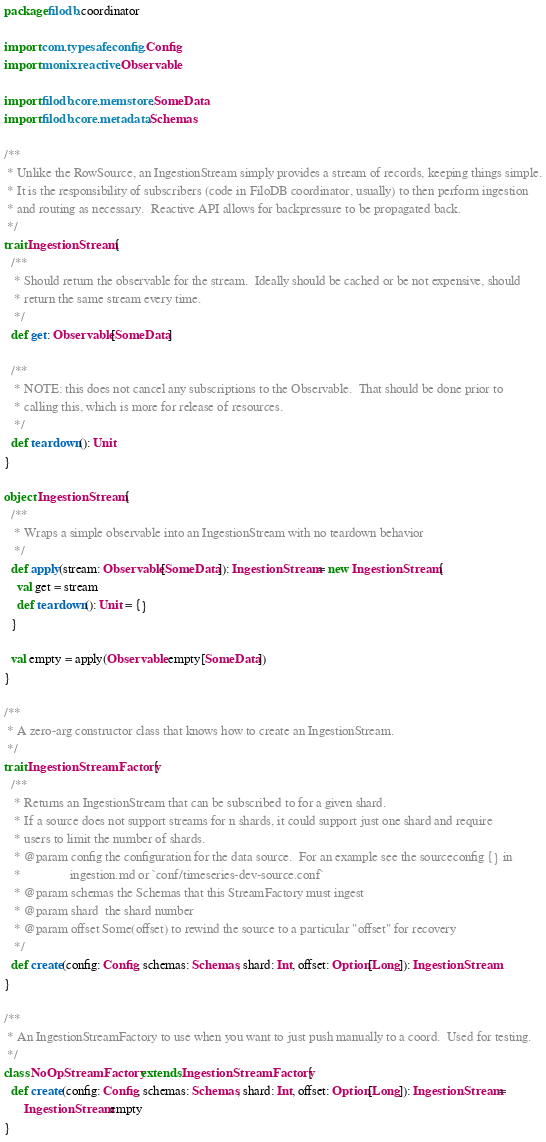Convert code to text. <code><loc_0><loc_0><loc_500><loc_500><_Scala_>package filodb.coordinator

import com.typesafe.config.Config
import monix.reactive.Observable

import filodb.core.memstore.SomeData
import filodb.core.metadata.Schemas

/**
 * Unlike the RowSource, an IngestionStream simply provides a stream of records, keeping things simple.
 * It is the responsibility of subscribers (code in FiloDB coordinator, usually) to then perform ingestion
 * and routing as necessary.  Reactive API allows for backpressure to be propagated back.
 */
trait IngestionStream {
  /**
   * Should return the observable for the stream.  Ideally should be cached or be not expensive, should
   * return the same stream every time.
   */
  def get: Observable[SomeData]

  /**
   * NOTE: this does not cancel any subscriptions to the Observable.  That should be done prior to
   * calling this, which is more for release of resources.
   */
  def teardown(): Unit
}

object IngestionStream {
  /**
   * Wraps a simple observable into an IngestionStream with no teardown behavior
   */
  def apply(stream: Observable[SomeData]): IngestionStream = new IngestionStream {
    val get = stream
    def teardown(): Unit = {}
  }

  val empty = apply(Observable.empty[SomeData])
}

/**
 * A zero-arg constructor class that knows how to create an IngestionStream.
 */
trait IngestionStreamFactory {
  /**
   * Returns an IngestionStream that can be subscribed to for a given shard.
   * If a source does not support streams for n shards, it could support just one shard and require
   * users to limit the number of shards.
   * @param config the configuration for the data source.  For an example see the sourceconfig {} in
   *               ingestion.md or `conf/timeseries-dev-source.conf`
   * @param schemas the Schemas that this StreamFactory must ingest
   * @param shard  the shard number
   * @param offset Some(offset) to rewind the source to a particular "offset" for recovery
   */
  def create(config: Config, schemas: Schemas, shard: Int, offset: Option[Long]): IngestionStream
}

/**
 * An IngestionStreamFactory to use when you want to just push manually to a coord.  Used for testing.
 */
class NoOpStreamFactory extends IngestionStreamFactory {
  def create(config: Config, schemas: Schemas, shard: Int, offset: Option[Long]): IngestionStream =
      IngestionStream.empty
}
</code> 